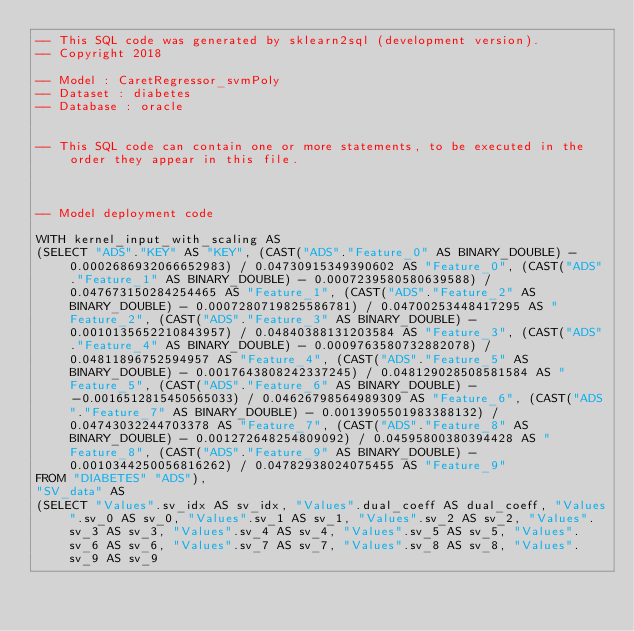<code> <loc_0><loc_0><loc_500><loc_500><_SQL_>-- This SQL code was generated by sklearn2sql (development version).
-- Copyright 2018

-- Model : CaretRegressor_svmPoly
-- Dataset : diabetes
-- Database : oracle


-- This SQL code can contain one or more statements, to be executed in the order they appear in this file.



-- Model deployment code

WITH kernel_input_with_scaling AS 
(SELECT "ADS"."KEY" AS "KEY", (CAST("ADS"."Feature_0" AS BINARY_DOUBLE) - 0.0002686932066652983) / 0.04730915349390602 AS "Feature_0", (CAST("ADS"."Feature_1" AS BINARY_DOUBLE) - 0.0007239580580639588) / 0.047673150284254465 AS "Feature_1", (CAST("ADS"."Feature_2" AS BINARY_DOUBLE) - 0.0007280719825586781) / 0.04700253448417295 AS "Feature_2", (CAST("ADS"."Feature_3" AS BINARY_DOUBLE) - 0.0010135652210843957) / 0.04840388131203584 AS "Feature_3", (CAST("ADS"."Feature_4" AS BINARY_DOUBLE) - 0.0009763580732882078) / 0.04811896752594957 AS "Feature_4", (CAST("ADS"."Feature_5" AS BINARY_DOUBLE) - 0.0017643808242337245) / 0.048129028508581584 AS "Feature_5", (CAST("ADS"."Feature_6" AS BINARY_DOUBLE) - -0.0016512815450565033) / 0.04626798564989309 AS "Feature_6", (CAST("ADS"."Feature_7" AS BINARY_DOUBLE) - 0.0013905501983388132) / 0.04743032244703378 AS "Feature_7", (CAST("ADS"."Feature_8" AS BINARY_DOUBLE) - 0.001272648254809092) / 0.04595800380394428 AS "Feature_8", (CAST("ADS"."Feature_9" AS BINARY_DOUBLE) - 0.0010344250056816262) / 0.04782938024075455 AS "Feature_9" 
FROM "DIABETES" "ADS"), 
"SV_data" AS 
(SELECT "Values".sv_idx AS sv_idx, "Values".dual_coeff AS dual_coeff, "Values".sv_0 AS sv_0, "Values".sv_1 AS sv_1, "Values".sv_2 AS sv_2, "Values".sv_3 AS sv_3, "Values".sv_4 AS sv_4, "Values".sv_5 AS sv_5, "Values".sv_6 AS sv_6, "Values".sv_7 AS sv_7, "Values".sv_8 AS sv_8, "Values".sv_9 AS sv_9 </code> 